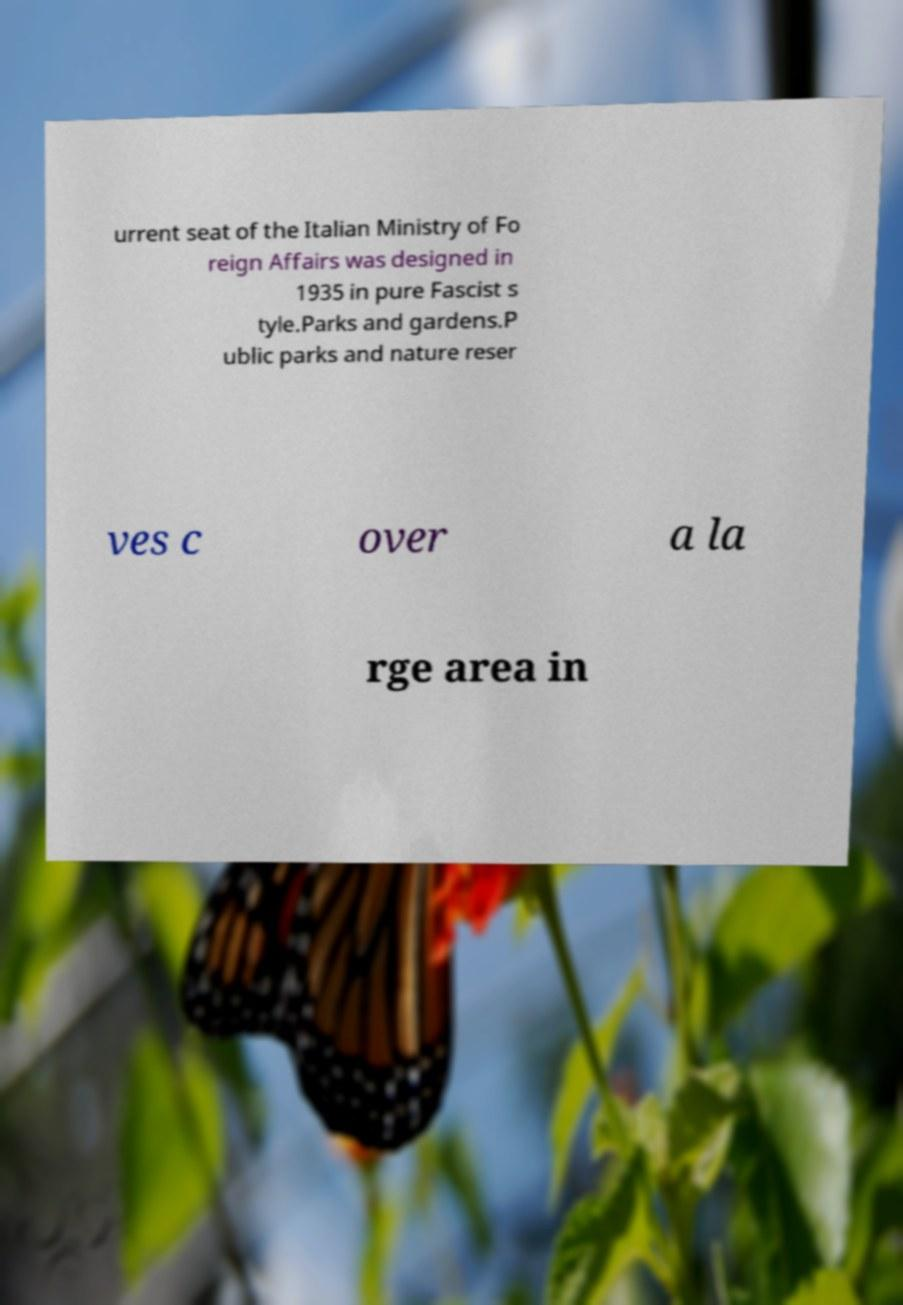There's text embedded in this image that I need extracted. Can you transcribe it verbatim? urrent seat of the Italian Ministry of Fo reign Affairs was designed in 1935 in pure Fascist s tyle.Parks and gardens.P ublic parks and nature reser ves c over a la rge area in 